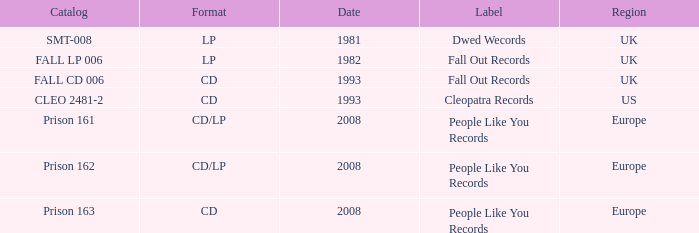Which Format has a Date of 1993, and a Catalog of cleo 2481-2? CD. 